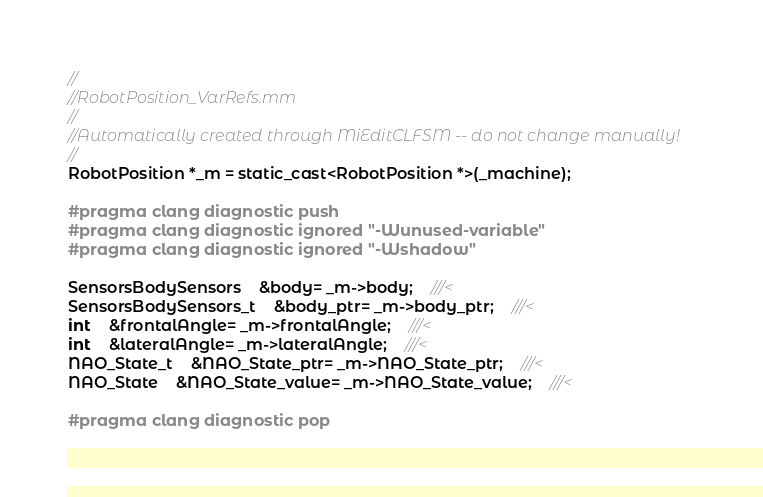Convert code to text. <code><loc_0><loc_0><loc_500><loc_500><_ObjectiveC_>//
//RobotPosition_VarRefs.mm
//
//Automatically created through MiEditCLFSM -- do not change manually!
//
RobotPosition *_m = static_cast<RobotPosition *>(_machine);

#pragma clang diagnostic push
#pragma clang diagnostic ignored "-Wunused-variable"
#pragma clang diagnostic ignored "-Wshadow"

SensorsBodySensors	&body= _m->body;	///<
SensorsBodySensors_t	&body_ptr= _m->body_ptr;	///<
int	&frontalAngle= _m->frontalAngle;	///<
int	&lateralAngle= _m->lateralAngle;	///<
NAO_State_t	&NAO_State_ptr= _m->NAO_State_ptr;	///<
NAO_State	&NAO_State_value= _m->NAO_State_value;	///<

#pragma clang diagnostic pop
</code> 